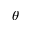<formula> <loc_0><loc_0><loc_500><loc_500>\theta</formula> 